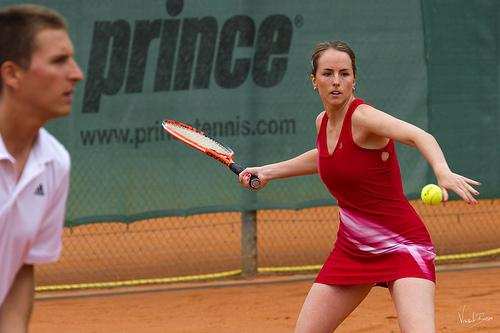Question: why is the girl raising the racket?
Choices:
A. To show it off.
B. To throw it.
C. To hand it to someone.
D. To hit the ball.
Answer with the letter. Answer: D Question: what is written on the background banner?
Choices:
A. Victory.
B. Chevrolet.
C. Prince.
D. Obama.
Answer with the letter. Answer: C Question: how is the girl?
Choices:
A. Running.
B. In motion.
C. Sitting.
D. Sleeping.
Answer with the letter. Answer: B 